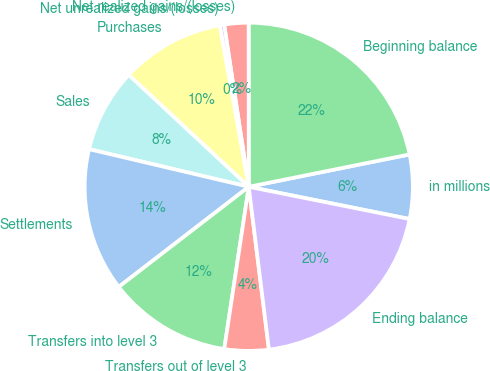Convert chart. <chart><loc_0><loc_0><loc_500><loc_500><pie_chart><fcel>in millions<fcel>Beginning balance<fcel>Net realized gains/(losses)<fcel>Net unrealized gains/(losses)<fcel>Purchases<fcel>Sales<fcel>Settlements<fcel>Transfers into level 3<fcel>Transfers out of level 3<fcel>Ending balance<nl><fcel>6.31%<fcel>21.85%<fcel>2.39%<fcel>0.44%<fcel>10.22%<fcel>8.26%<fcel>14.13%<fcel>12.17%<fcel>4.35%<fcel>19.89%<nl></chart> 